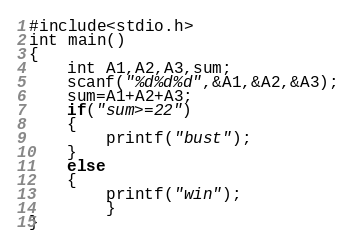Convert code to text. <code><loc_0><loc_0><loc_500><loc_500><_C#_>#include<stdio.h>
int main()
{
	int A1,A2,A3,sum;
	scanf("%d%d%d",&A1,&A2,&A3);
	sum=A1+A2+A3;
	if("sum>=22")
	{
		printf("bust");
	}
	else
	{
		printf("win");
		}	
}</code> 